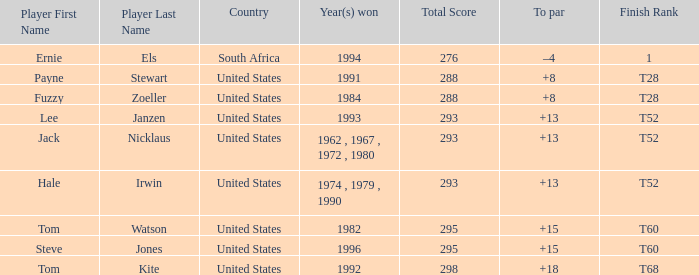Who is the player from the United States with a total less than 293 and won in 1984? Fuzzy Zoeller. 